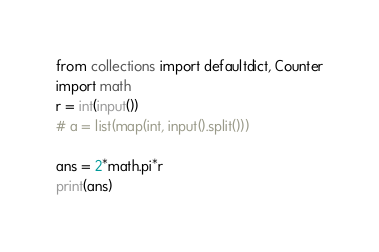Convert code to text. <code><loc_0><loc_0><loc_500><loc_500><_Python_>from collections import defaultdict, Counter
import math
r = int(input())
# a = list(map(int, input().split()))

ans = 2*math.pi*r
print(ans)</code> 